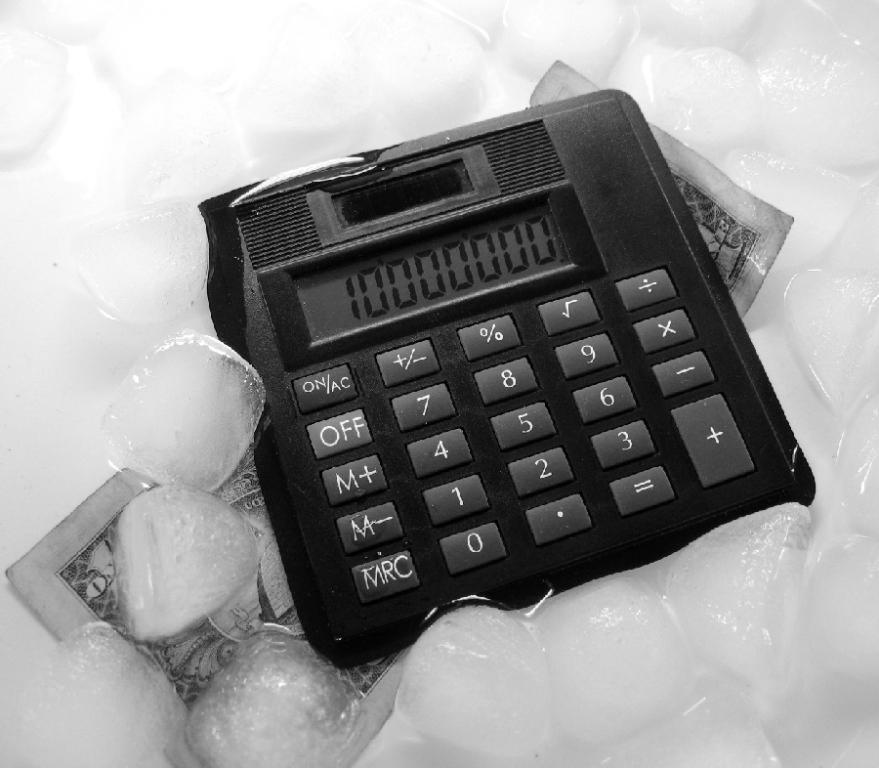Provide a one-sentence caption for the provided image. A calculator with a  number 1 with a bunch of  zeros,  on top of a bill and ice. 